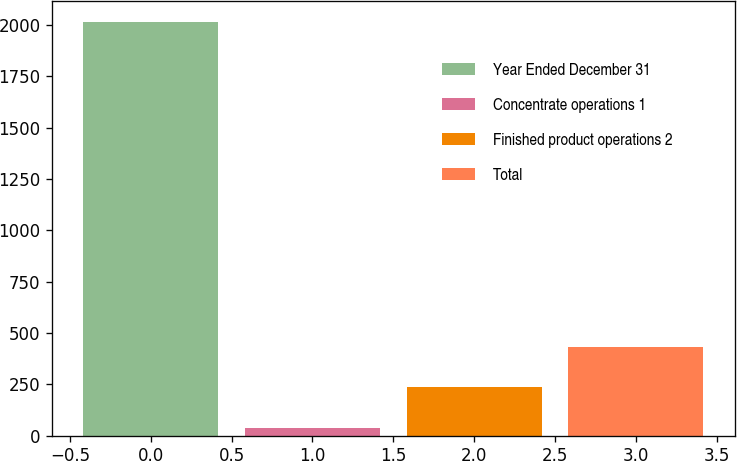Convert chart to OTSL. <chart><loc_0><loc_0><loc_500><loc_500><bar_chart><fcel>Year Ended December 31<fcel>Concentrate operations 1<fcel>Finished product operations 2<fcel>Total<nl><fcel>2015<fcel>37<fcel>234.8<fcel>432.6<nl></chart> 